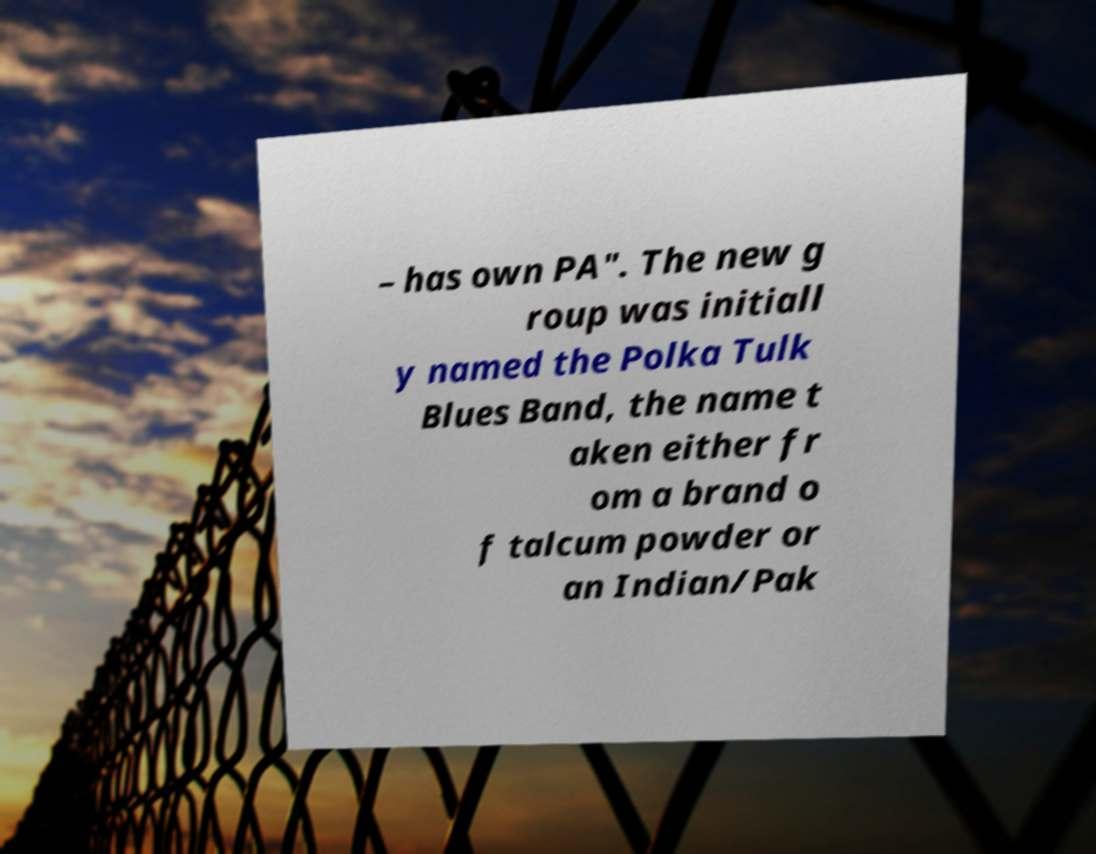Please identify and transcribe the text found in this image. – has own PA". The new g roup was initiall y named the Polka Tulk Blues Band, the name t aken either fr om a brand o f talcum powder or an Indian/Pak 